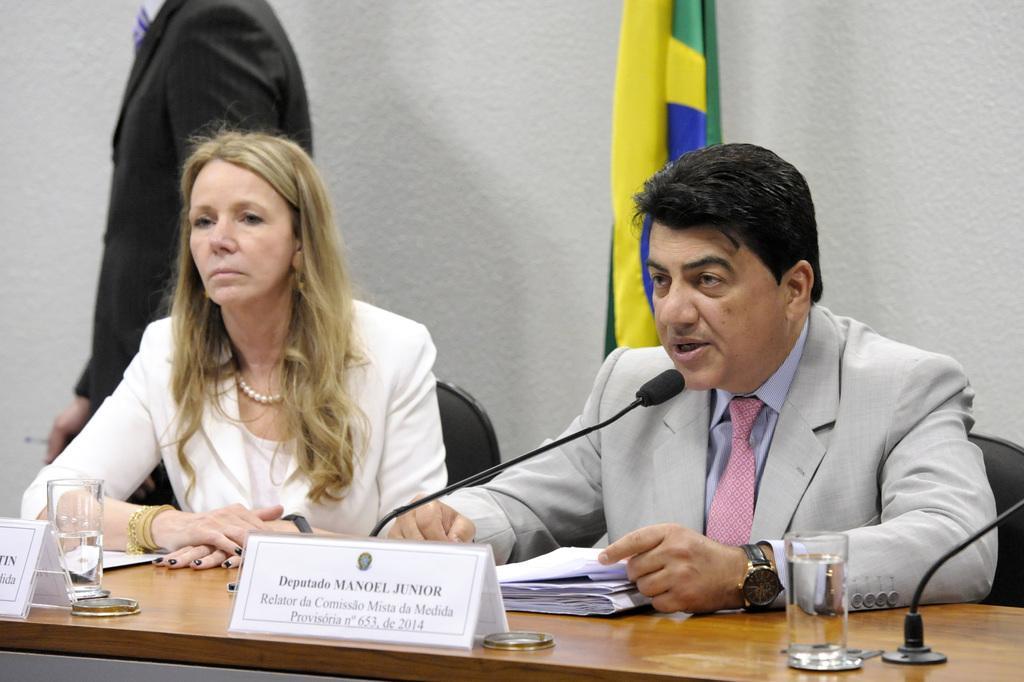How would you summarize this image in a sentence or two? In the picture we can see a man and a woman are sitting near the desk and the man is talking into the microphone and on the desk, we can see the name boards, glasses of water, and some papers and behind them we can see a flag and a person standing near the wall. 